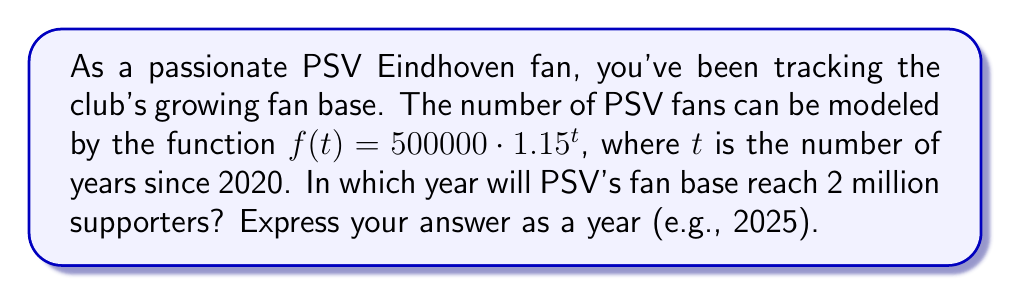Could you help me with this problem? To solve this problem, we need to use logarithms to find when $f(t) = 2000000$. Let's approach this step-by-step:

1) We start with the equation:
   $500000 \cdot 1.15^t = 2000000$

2) Divide both sides by 500000:
   $1.15^t = 4$

3) Take the logarithm (base 1.15) of both sides:
   $\log_{1.15}(1.15^t) = \log_{1.15}(4)$

4) Using the logarithm property $\log_a(a^x) = x$, we get:
   $t = \log_{1.15}(4)$

5) We can change this to a natural logarithm:
   $t = \frac{\ln(4)}{\ln(1.15)}$

6) Calculate:
   $t \approx 9.634$ years

7) Since $t$ is the number of years since 2020, we add this to 2020:
   $2020 + 9.634 \approx 2029.634$

8) Rounding up to the nearest year (as we're looking for when it will reach 2 million), we get 2030.
Answer: 2030 